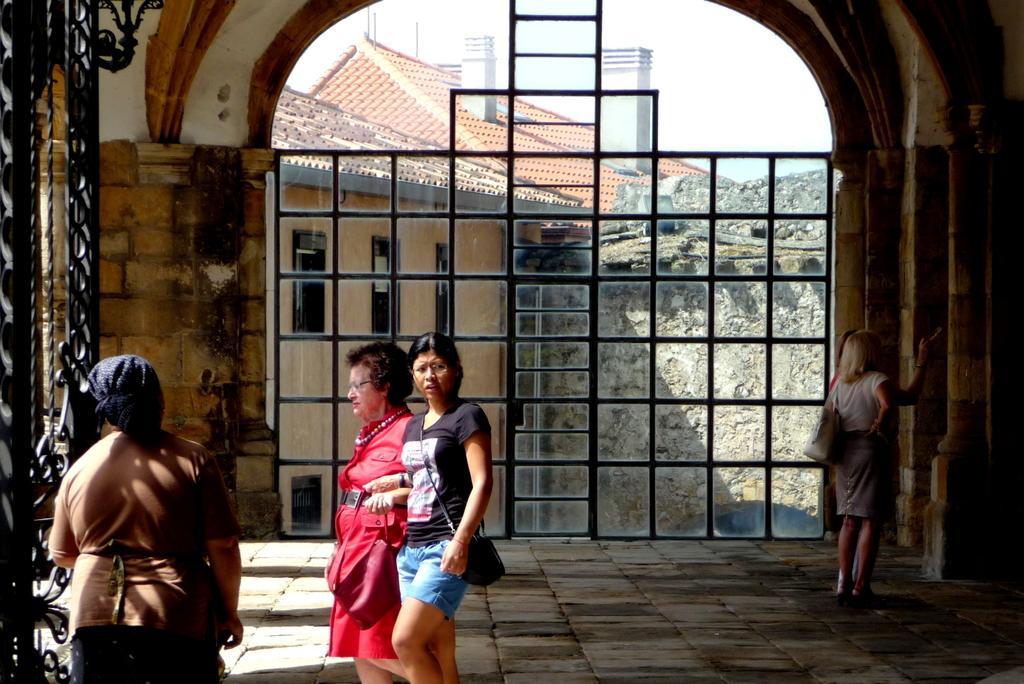Please provide a concise description of this image. In this picture there are few persons standing and there is a black fence in the left corner and there is a fence and few buildings where one building among them is having two chimneys on it in the background. 